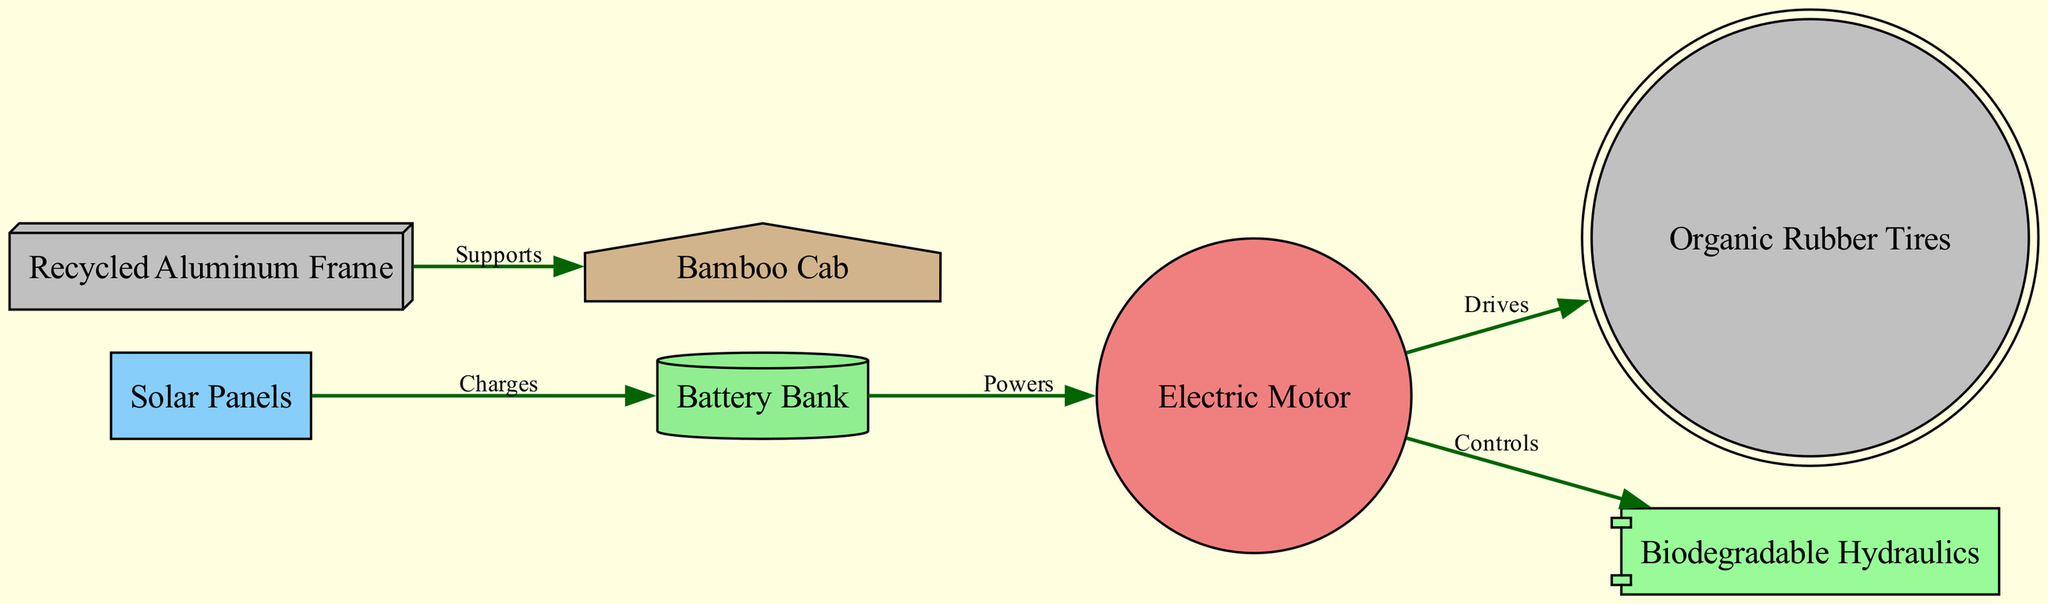What is the power source for the Electric Motor? The Electric Motor is powered by the Battery Bank, which receives its charge from the Solar Panels according to the directed edges in the diagram.
Answer: Battery Bank How many components are there in the diagram? By counting the nodes listed in the diagram, we find there are 7 components (Solar Panels, Battery Bank, Electric Motor, Recycled Aluminum Frame, Bamboo Cab, Organic Rubber Tires, and Biodegradable Hydraulics).
Answer: 7 What role do the Solar Panels play in the system? The Solar Panels charge the Battery Bank as indicated by the edge labeled "Charges" that connects these two nodes.
Answer: Charges Which component controls the Biodegradable Hydraulics? The Electric Motor controls the Biodegradable Hydraulics, as specified by the directed edge from the Electric Motor to the Biodegradable Hydraulics in the diagram.
Answer: Electric Motor What does the Recycled Aluminum Frame support? The Recycled Aluminum Frame supports the Bamboo Cab, which is shown by the directed edge labeled "Supports" connecting these two components.
Answer: Bamboo Cab How does the Electric Motor affect the Organic Rubber Tires? The Electric Motor drives the Organic Rubber Tires, indicated by the edge connecting these two components with the label "Drives".
Answer: Drives What materials are used in the tractor's frame and cab? The frame is made of Recycled Aluminum and the cab is made of Bamboo, as indicated by the respective nodes in the diagram.
Answer: Recycled Aluminum, Bamboo What type of tires are used on the tractor? The tires are made of Organic Rubber, which is stated as the label for the node connected to the Electric Motor.
Answer: Organic Rubber Tires 